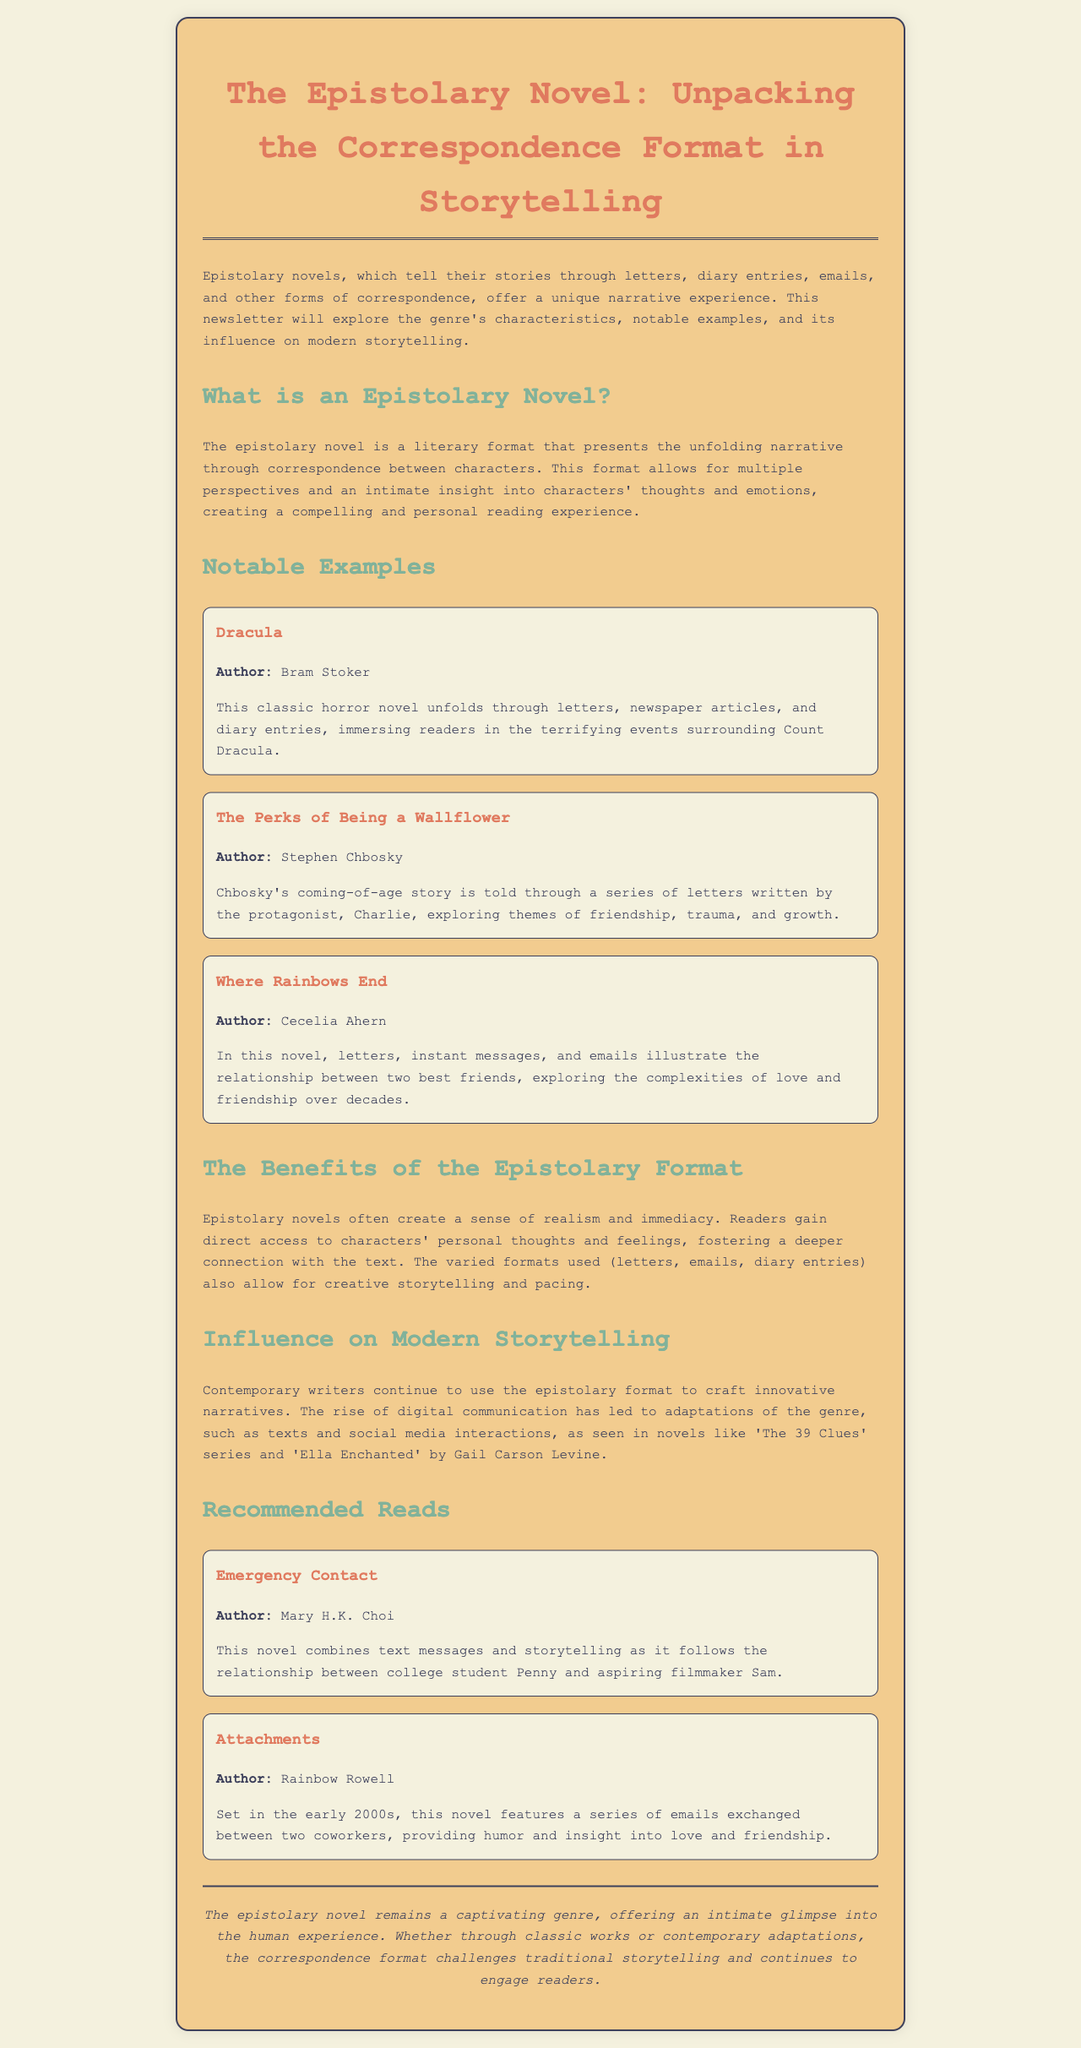What is an epistolary novel? An epistolary novel is a literary format that presents the unfolding narrative through correspondence between characters.
Answer: A literary format Who is the author of "Dracula"? The author of "Dracula" is mentioned in the notable examples section of the document.
Answer: Bram Stoker What type of content is featured in "The Perks of Being a Wallflower"? This book is described in the document as telling a coming-of-age story through a series of letters written by the protagonist.
Answer: Letters Name one benefit of the epistolary format. The document highlights benefits of this format, including direct access to characters' personal thoughts and feelings.
Answer: Realism Which two novels are mentioned under "Recommended Reads"? The document lists titles under the recommended reads section that exemplify the epistolary format.
Answer: Emergency Contact, Attachments What is the primary theme explored in "Where Rainbows End"? The summary provided in the document focuses on the relationship between characters over time.
Answer: Love and friendship Which modern adaptations of the epistolary format are mentioned? The document references contemporary novels that utilize modern forms of correspondence.
Answer: The 39 Clues series, Ella Enchanted How does the epistolary format affect storytelling? The document discusses how it fosters creative storytelling and pacing through varied formats.
Answer: Creative storytelling 